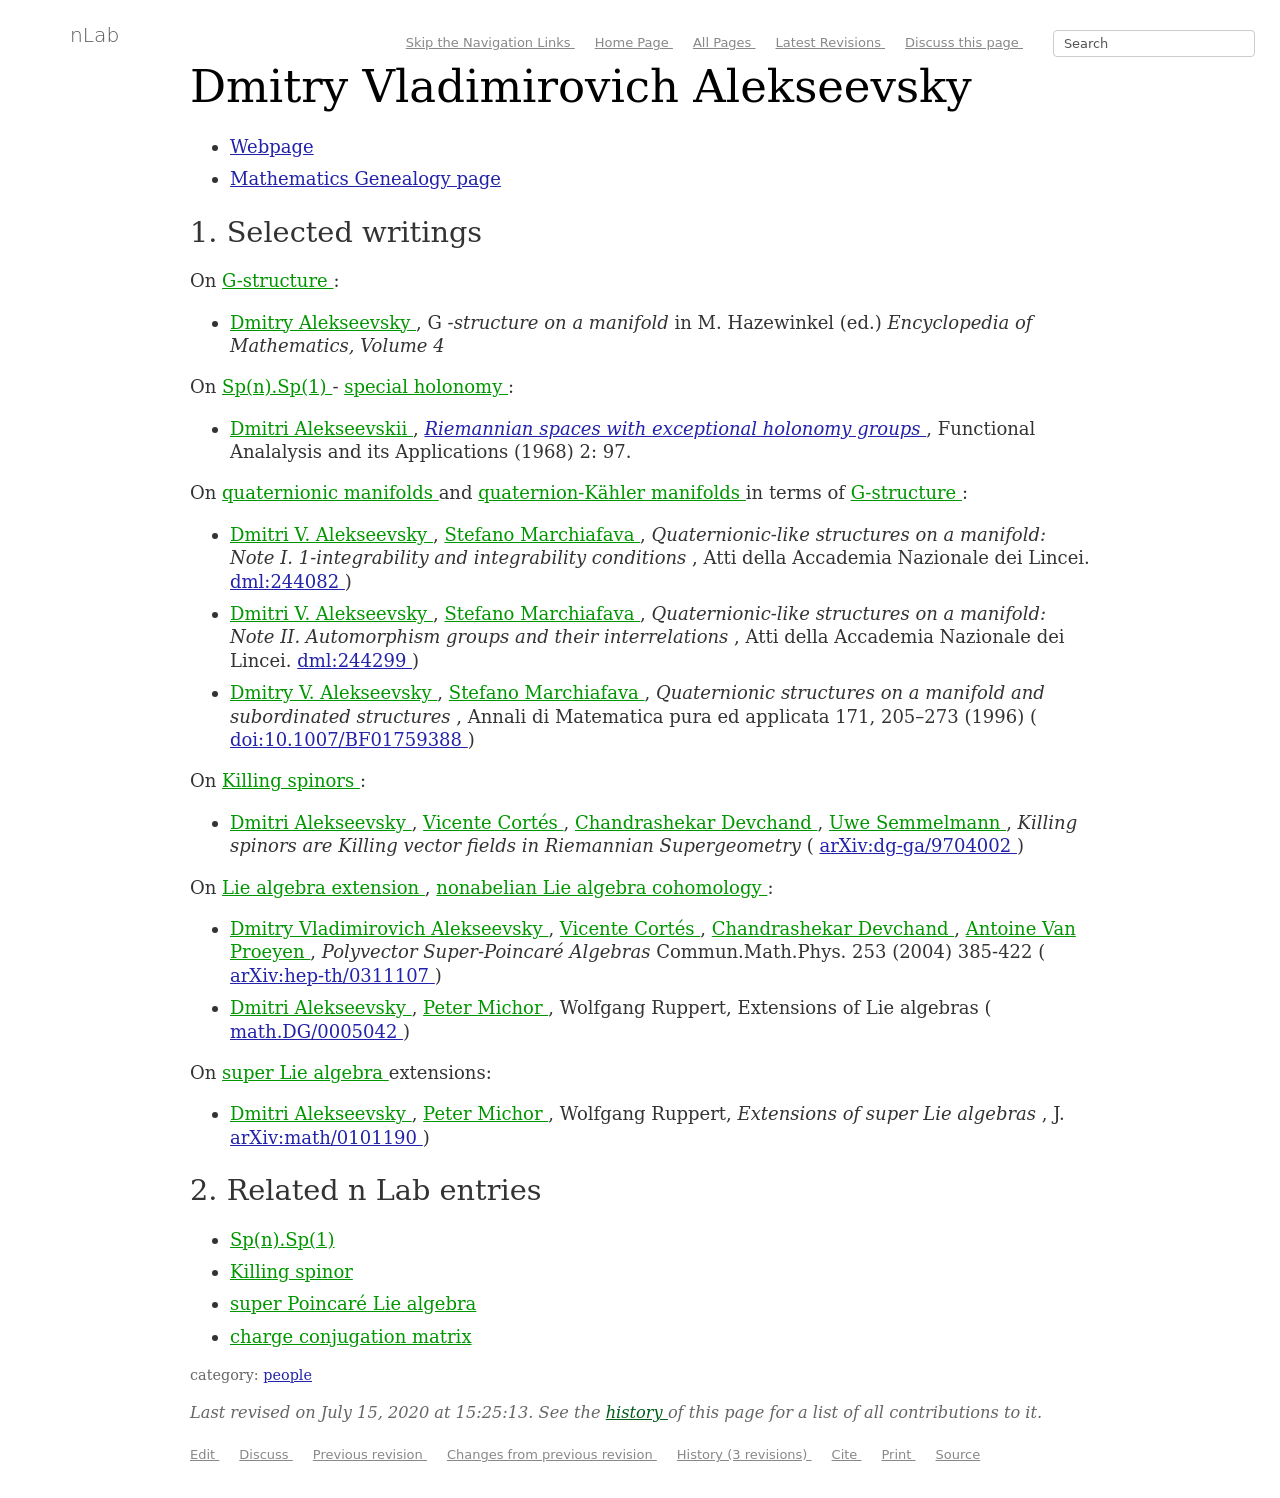What's the relevance of 'Killing spinors' as mentioned in his selected writings? Killing spinors play a crucial role in the study of spacetime geometries in the field of general relativity and string theory. They help in identifying spaces with special holonomy, which are important for theoretical physics, including string theory, as they allow for solutions that preserve some supersymmetries.  Can you explain further how this intersects with theoretical physics? In theoretical physics, particularly in supergravity and string theories, Killing spinors help in constructing models of our universe that include additional dimensions, potentially explaining fundamental properties of particles and forces. They provide mathematical tools to explore and confirm the physical theories predicting the universe's multi-dimensional nature. 